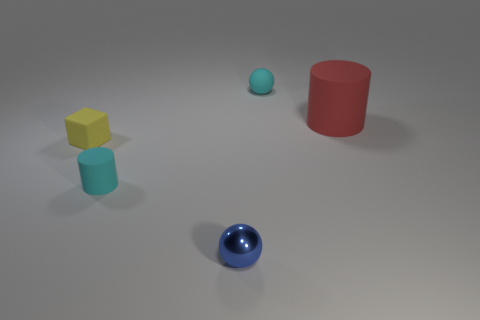Subtract all yellow cylinders. Subtract all green cubes. How many cylinders are left? 2 Add 4 blocks. How many objects exist? 9 Subtract all blocks. How many objects are left? 4 Subtract 0 green balls. How many objects are left? 5 Subtract all large yellow rubber cylinders. Subtract all small cyan cylinders. How many objects are left? 4 Add 2 metal objects. How many metal objects are left? 3 Add 3 small cyan rubber spheres. How many small cyan rubber spheres exist? 4 